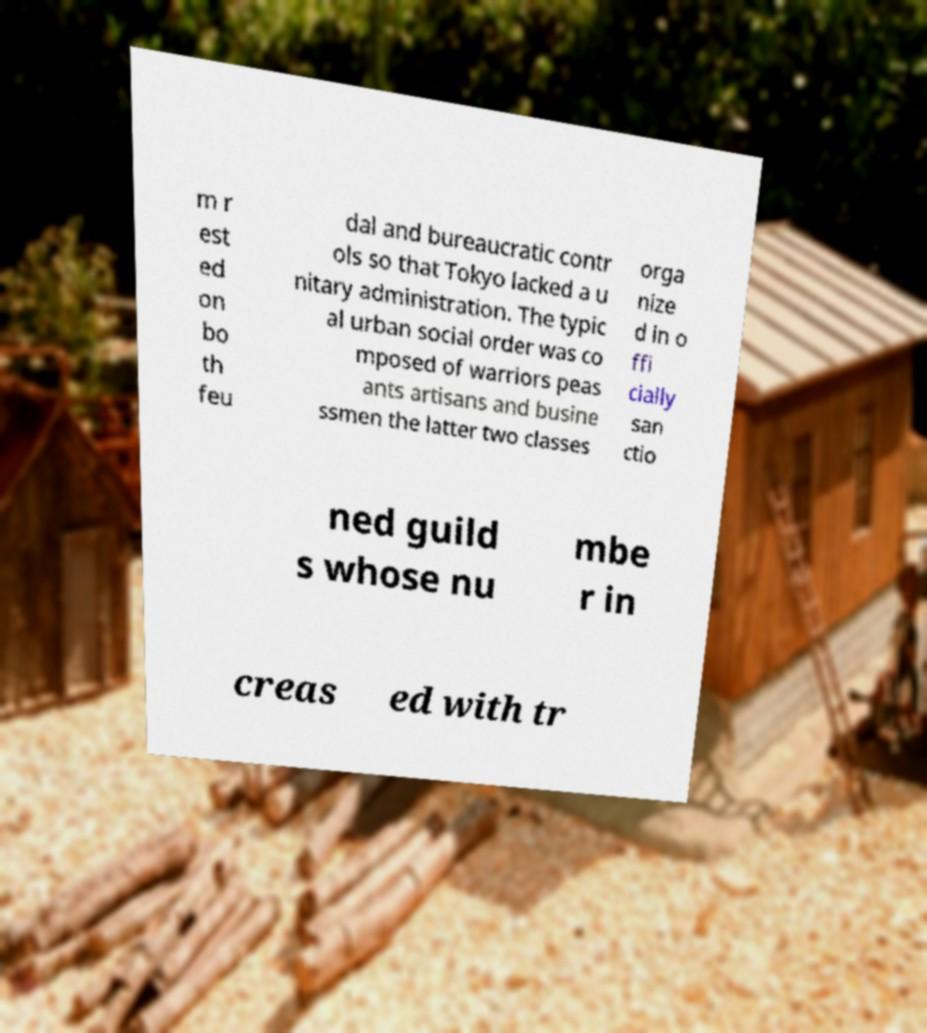Can you accurately transcribe the text from the provided image for me? m r est ed on bo th feu dal and bureaucratic contr ols so that Tokyo lacked a u nitary administration. The typic al urban social order was co mposed of warriors peas ants artisans and busine ssmen the latter two classes orga nize d in o ffi cially san ctio ned guild s whose nu mbe r in creas ed with tr 